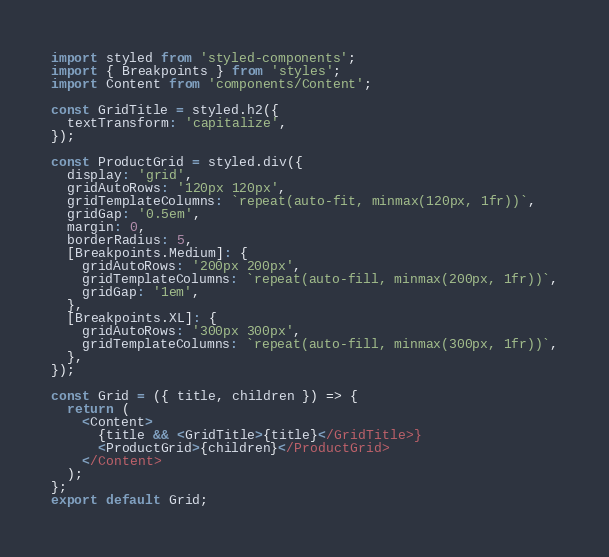Convert code to text. <code><loc_0><loc_0><loc_500><loc_500><_JavaScript_>import styled from 'styled-components';
import { Breakpoints } from 'styles';
import Content from 'components/Content';

const GridTitle = styled.h2({
  textTransform: 'capitalize',
});

const ProductGrid = styled.div({
  display: 'grid',
  gridAutoRows: '120px 120px',
  gridTemplateColumns: `repeat(auto-fit, minmax(120px, 1fr))`,
  gridGap: '0.5em',
  margin: 0,
  borderRadius: 5,
  [Breakpoints.Medium]: {
    gridAutoRows: '200px 200px',
    gridTemplateColumns: `repeat(auto-fill, minmax(200px, 1fr))`,
    gridGap: '1em',
  },
  [Breakpoints.XL]: {
    gridAutoRows: '300px 300px',
    gridTemplateColumns: `repeat(auto-fill, minmax(300px, 1fr))`,
  },
});

const Grid = ({ title, children }) => {
  return (
    <Content>
      {title && <GridTitle>{title}</GridTitle>}
      <ProductGrid>{children}</ProductGrid>
    </Content>
  );
};
export default Grid;
</code> 